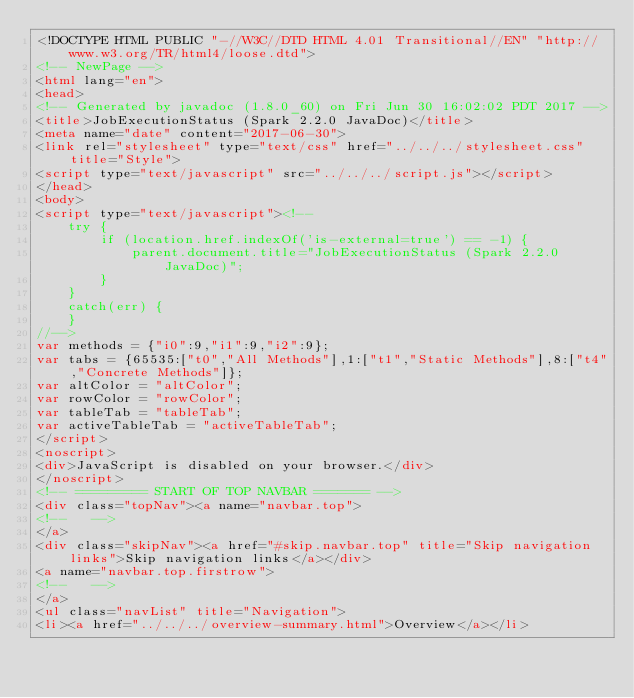<code> <loc_0><loc_0><loc_500><loc_500><_HTML_><!DOCTYPE HTML PUBLIC "-//W3C//DTD HTML 4.01 Transitional//EN" "http://www.w3.org/TR/html4/loose.dtd">
<!-- NewPage -->
<html lang="en">
<head>
<!-- Generated by javadoc (1.8.0_60) on Fri Jun 30 16:02:02 PDT 2017 -->
<title>JobExecutionStatus (Spark 2.2.0 JavaDoc)</title>
<meta name="date" content="2017-06-30">
<link rel="stylesheet" type="text/css" href="../../../stylesheet.css" title="Style">
<script type="text/javascript" src="../../../script.js"></script>
</head>
<body>
<script type="text/javascript"><!--
    try {
        if (location.href.indexOf('is-external=true') == -1) {
            parent.document.title="JobExecutionStatus (Spark 2.2.0 JavaDoc)";
        }
    }
    catch(err) {
    }
//-->
var methods = {"i0":9,"i1":9,"i2":9};
var tabs = {65535:["t0","All Methods"],1:["t1","Static Methods"],8:["t4","Concrete Methods"]};
var altColor = "altColor";
var rowColor = "rowColor";
var tableTab = "tableTab";
var activeTableTab = "activeTableTab";
</script>
<noscript>
<div>JavaScript is disabled on your browser.</div>
</noscript>
<!-- ========= START OF TOP NAVBAR ======= -->
<div class="topNav"><a name="navbar.top">
<!--   -->
</a>
<div class="skipNav"><a href="#skip.navbar.top" title="Skip navigation links">Skip navigation links</a></div>
<a name="navbar.top.firstrow">
<!--   -->
</a>
<ul class="navList" title="Navigation">
<li><a href="../../../overview-summary.html">Overview</a></li></code> 